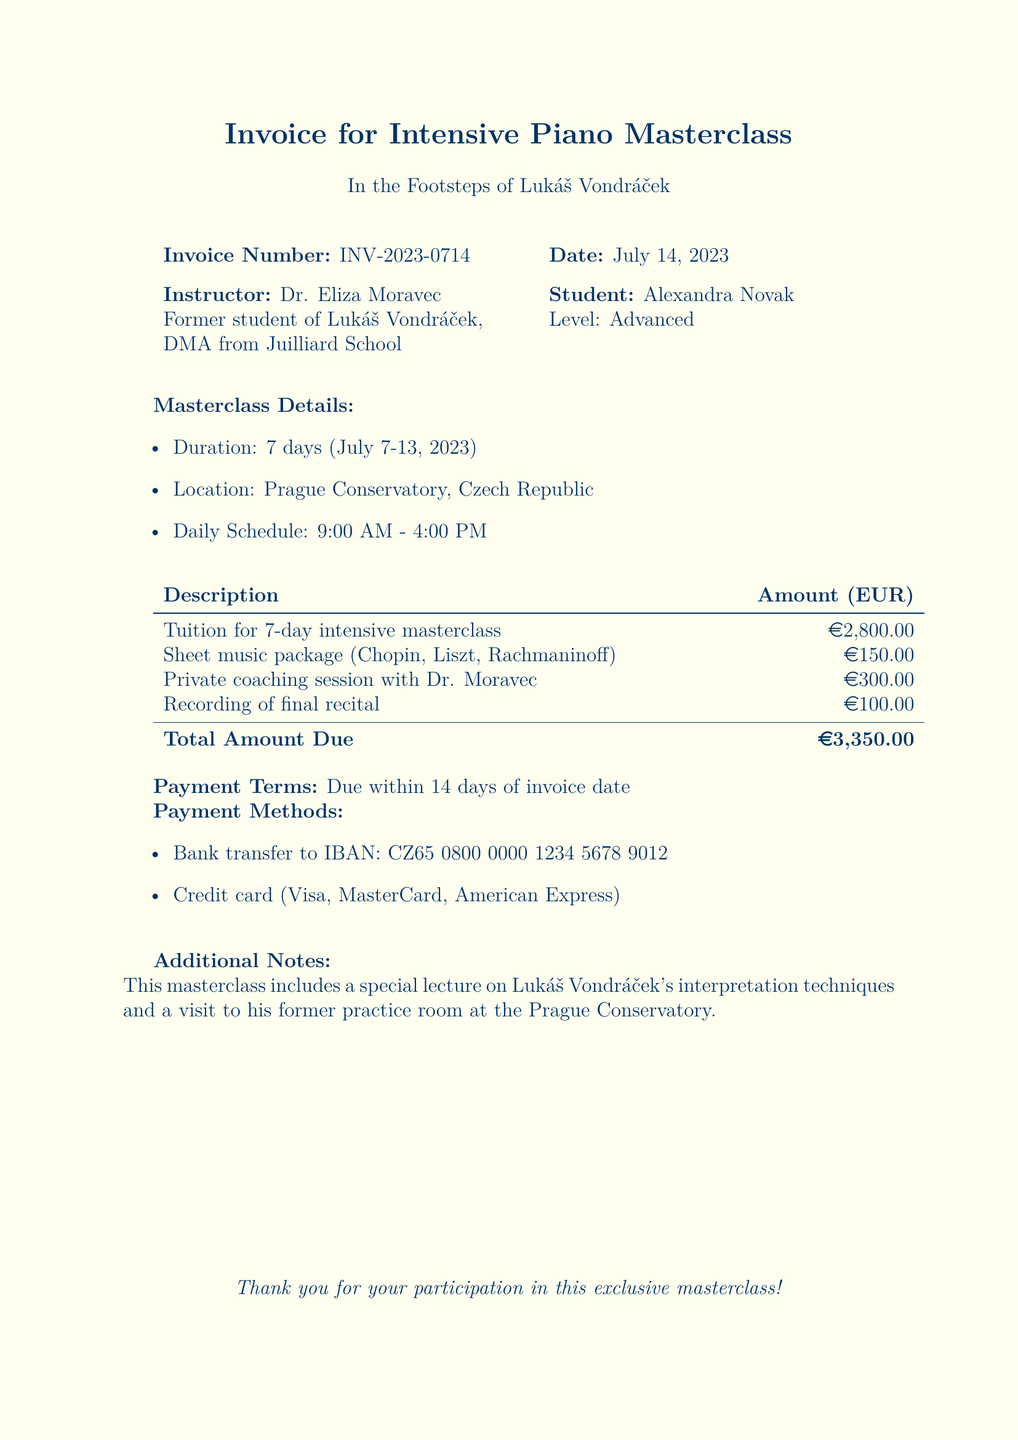what is the invoice number? The invoice number is stated clearly in the document as INV-2023-0714.
Answer: INV-2023-0714 who is the instructor of the masterclass? The instructor's name is mentioned in the document as Dr. Eliza Moravec.
Answer: Dr. Eliza Moravec what are the dates of the masterclass? The document specifies the duration of the masterclass from July 7 to July 13, 2023.
Answer: July 7-13, 2023 what is the total amount due? The total amount due is calculated and presented in the document as €3,350.00.
Answer: €3,350.00 how long is the daily schedule for the masterclass? The daily schedule is indicated in the document as 9:00 AM to 4:00 PM.
Answer: 9:00 AM - 4:00 PM what payment methods are accepted? The document lists bank transfer and credit card as the accepted payment methods.
Answer: Bank transfer, credit card what special lecture is included in the masterclass? The document notes a special lecture on Lukáš Vondráček's interpretation techniques.
Answer: Lukáš Vondráček's interpretation techniques what is the cost of the sheet music package? The cost for the sheet music package as mentioned in the document is €150.00.
Answer: €150.00 what is the duration of the masterclass? The duration of the masterclass is mentioned as 7 days.
Answer: 7 days 